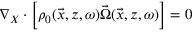Convert formula to latex. <formula><loc_0><loc_0><loc_500><loc_500>\begin{array} { r } { \nabla _ { X } \cdot \left [ \rho _ { 0 } ( \vec { x } , z , \omega ) \vec { \Omega } ( \vec { x } , z , \omega ) \right ] = 0 } \end{array}</formula> 